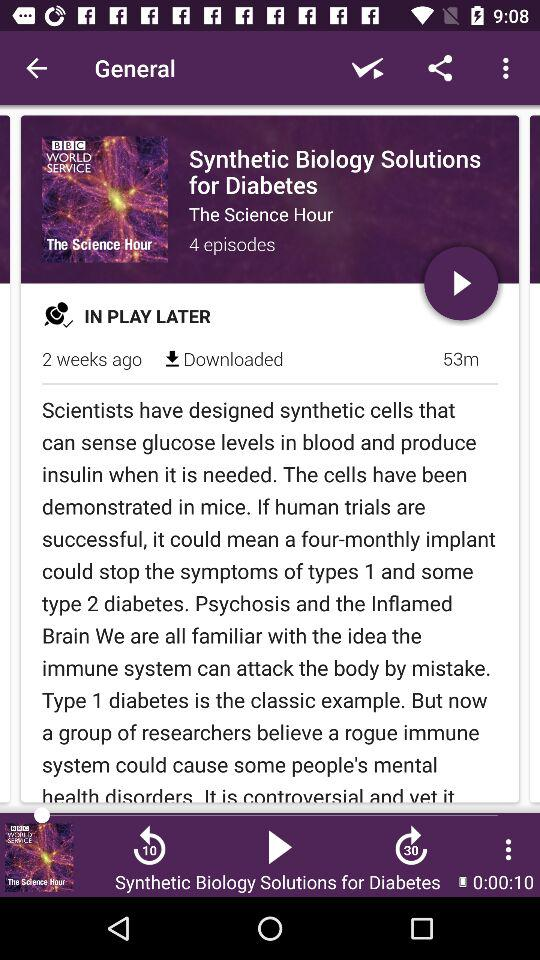How many episodes are downloaded?
When the provided information is insufficient, respond with <no answer>. <no answer> 